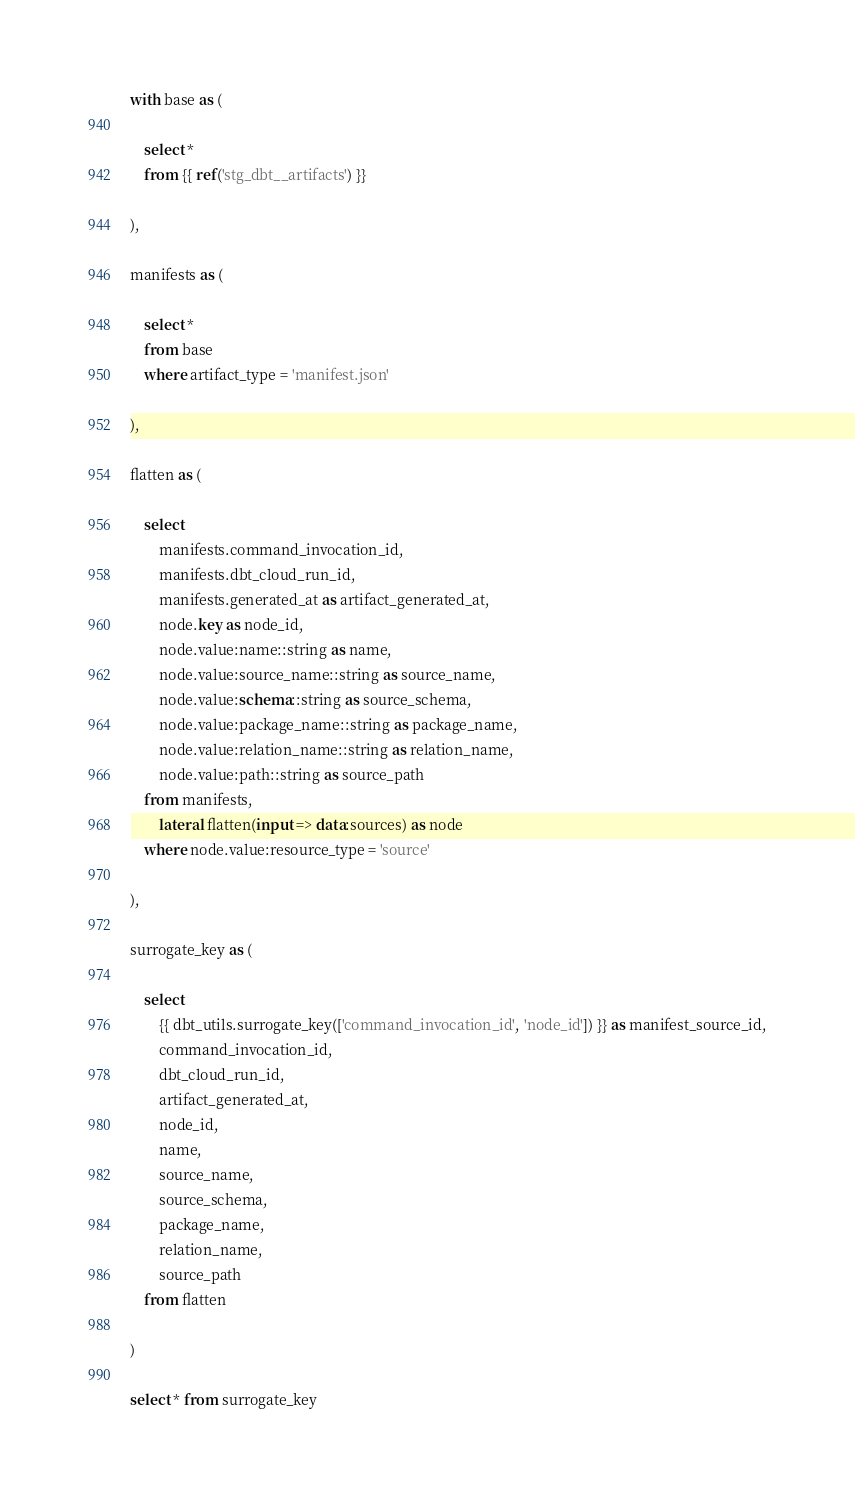Convert code to text. <code><loc_0><loc_0><loc_500><loc_500><_SQL_>with base as (

    select *
    from {{ ref('stg_dbt__artifacts') }}

),

manifests as (

    select *
    from base
    where artifact_type = 'manifest.json'

),

flatten as (

    select
        manifests.command_invocation_id,
        manifests.dbt_cloud_run_id,
        manifests.generated_at as artifact_generated_at,
        node.key as node_id,
        node.value:name::string as name,
        node.value:source_name::string as source_name,
        node.value:schema::string as source_schema,
        node.value:package_name::string as package_name,
        node.value:relation_name::string as relation_name,
        node.value:path::string as source_path
    from manifests,
        lateral flatten(input => data:sources) as node
    where node.value:resource_type = 'source'

),

surrogate_key as (

    select
        {{ dbt_utils.surrogate_key(['command_invocation_id', 'node_id']) }} as manifest_source_id,
        command_invocation_id,
        dbt_cloud_run_id,
        artifact_generated_at,
        node_id,
        name,
        source_name,
        source_schema,
        package_name,
        relation_name,
        source_path
    from flatten

)

select * from surrogate_key
</code> 